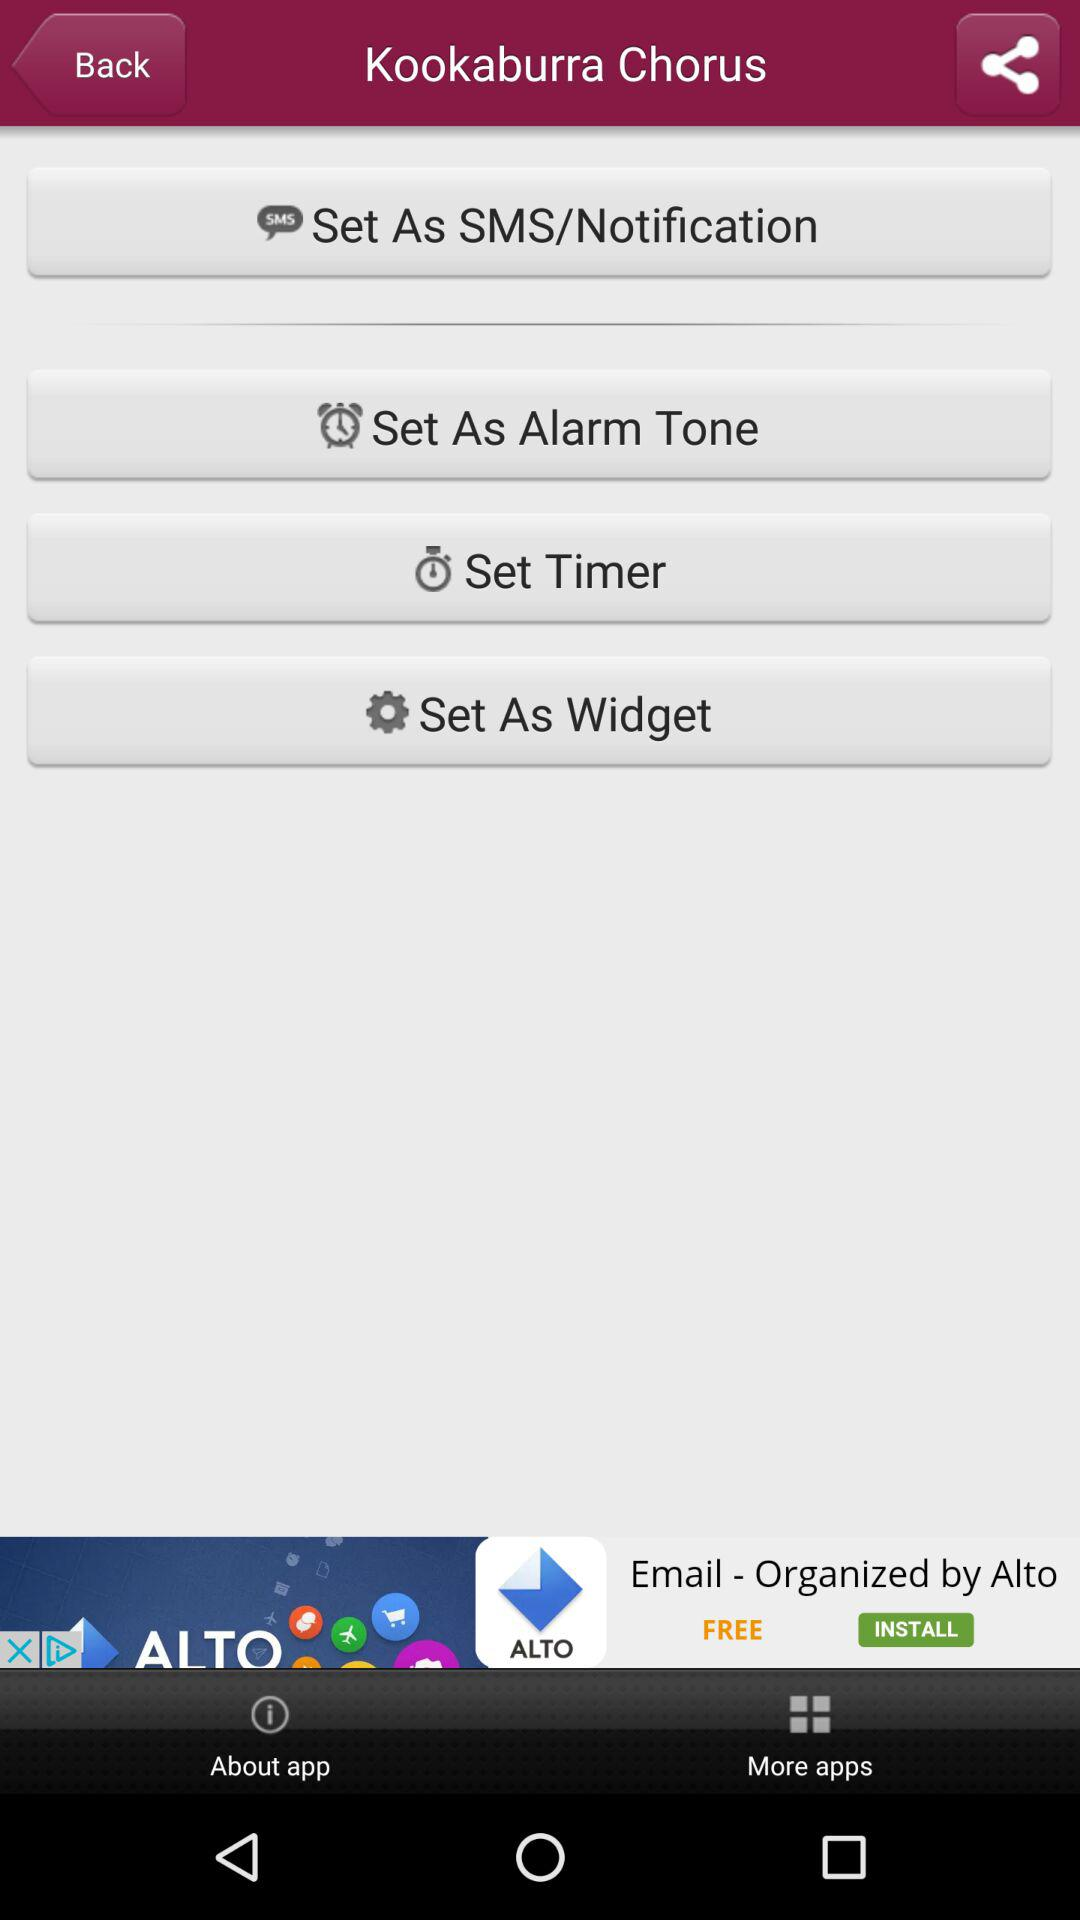What is the name of the application? The application name is "Kookaburra Chorus". 